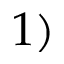<formula> <loc_0><loc_0><loc_500><loc_500>1 )</formula> 